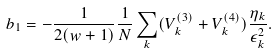<formula> <loc_0><loc_0><loc_500><loc_500>b _ { 1 } = - \frac { 1 } { 2 ( w + 1 ) } \frac { 1 } { N } \sum _ { k } ( V _ { k } ^ { ( 3 ) } + V _ { k } ^ { ( 4 ) } ) \frac { \eta _ { k } } { \epsilon _ { k } ^ { 2 } } .</formula> 